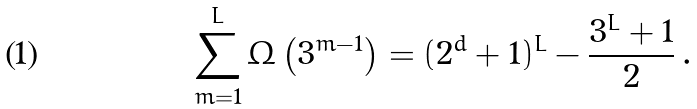<formula> <loc_0><loc_0><loc_500><loc_500>\sum _ { m = 1 } ^ { L } \Omega \left ( 3 ^ { m - 1 } \right ) = ( 2 ^ { d } + 1 ) ^ { L } - \frac { 3 ^ { L } + 1 } { 2 } \, .</formula> 